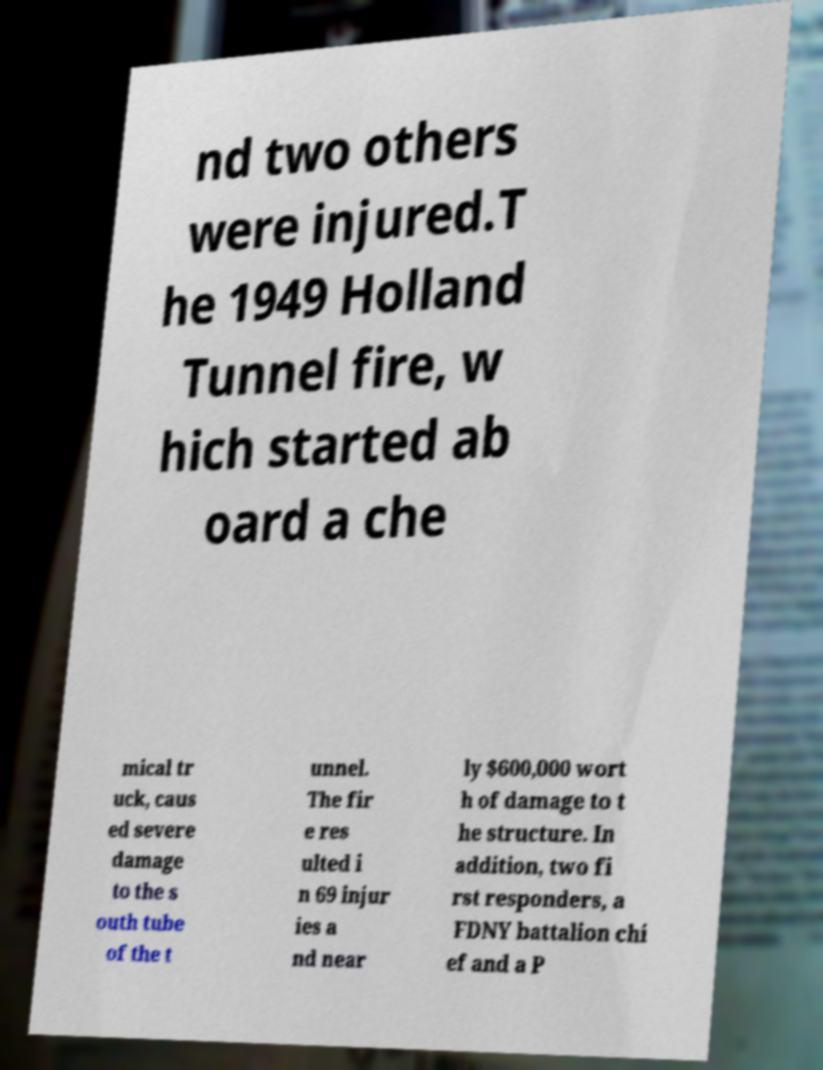Please identify and transcribe the text found in this image. nd two others were injured.T he 1949 Holland Tunnel fire, w hich started ab oard a che mical tr uck, caus ed severe damage to the s outh tube of the t unnel. The fir e res ulted i n 69 injur ies a nd near ly $600,000 wort h of damage to t he structure. In addition, two fi rst responders, a FDNY battalion chi ef and a P 